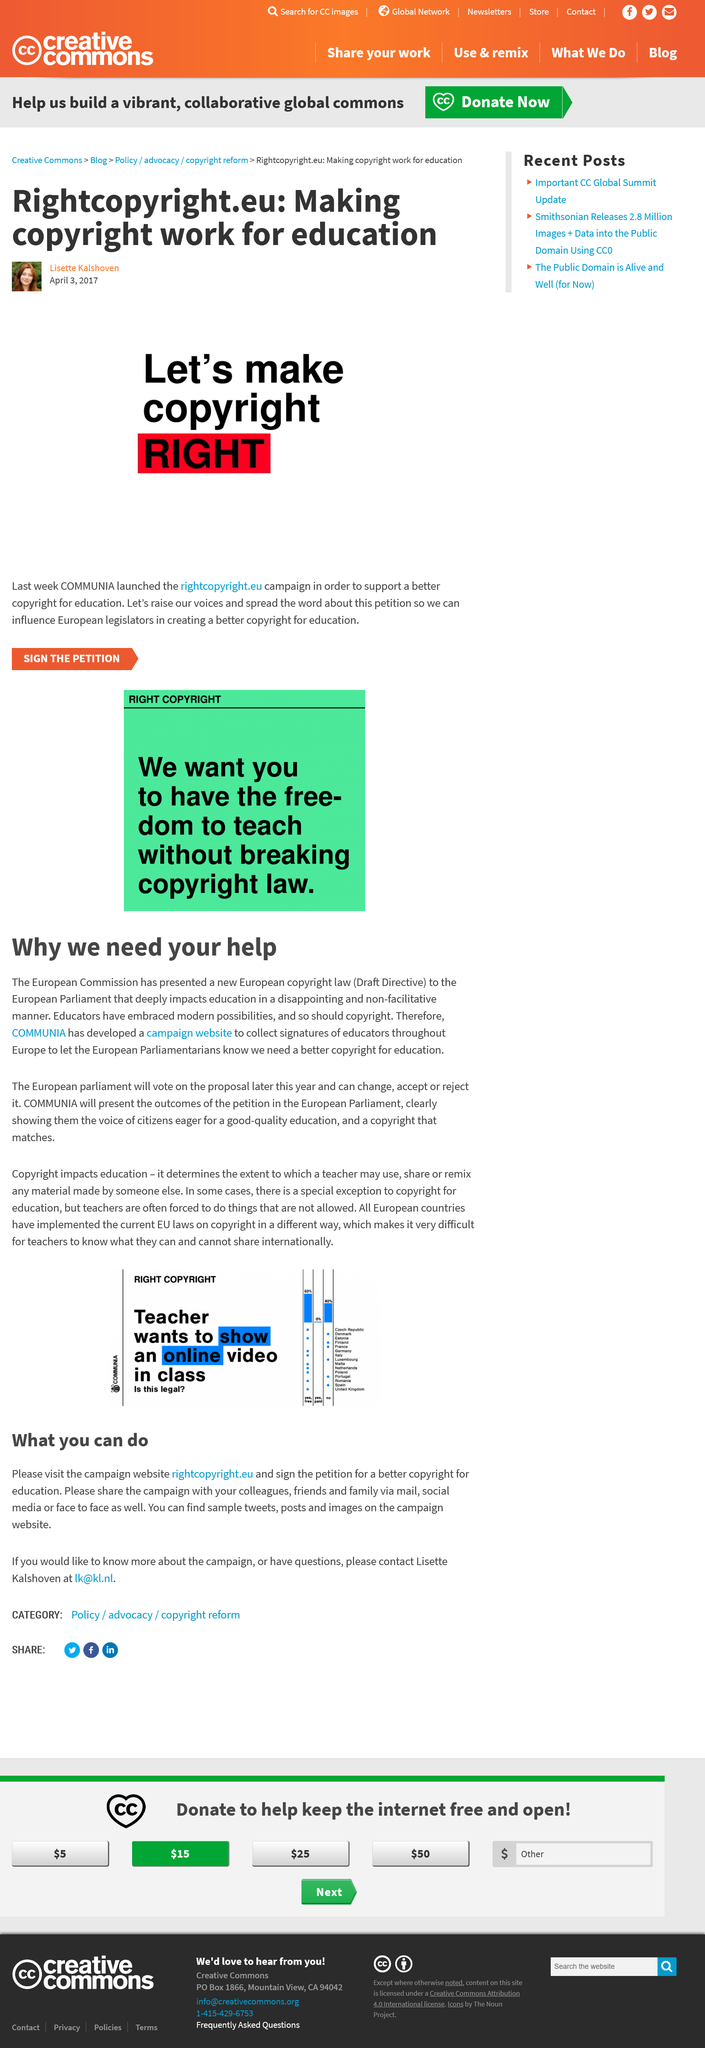Mention a couple of crucial points in this snapshot. COMMUNIA launched rightcopyright.eu. The presented European copyright law is called the Draft Directive. COMMUNIA has developed the campaign website. Rightcopyright.eu was launched by COMMUNIA in 2017. Rightcopyright.eu aims to ensure that copyright laws benefit education by effectively facilitating the use of copyrighted materials for educational purposes. 